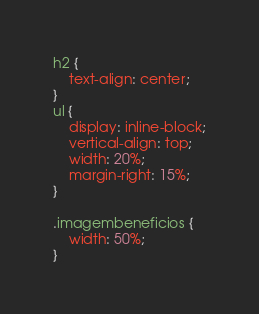<code> <loc_0><loc_0><loc_500><loc_500><_CSS_>
h2 {
	text-align: center;
}
ul {
	display: inline-block;
	vertical-align: top;
	width: 20%;
	margin-right: 15%;
}

.imagembeneficios {
	width: 50%;
}</code> 